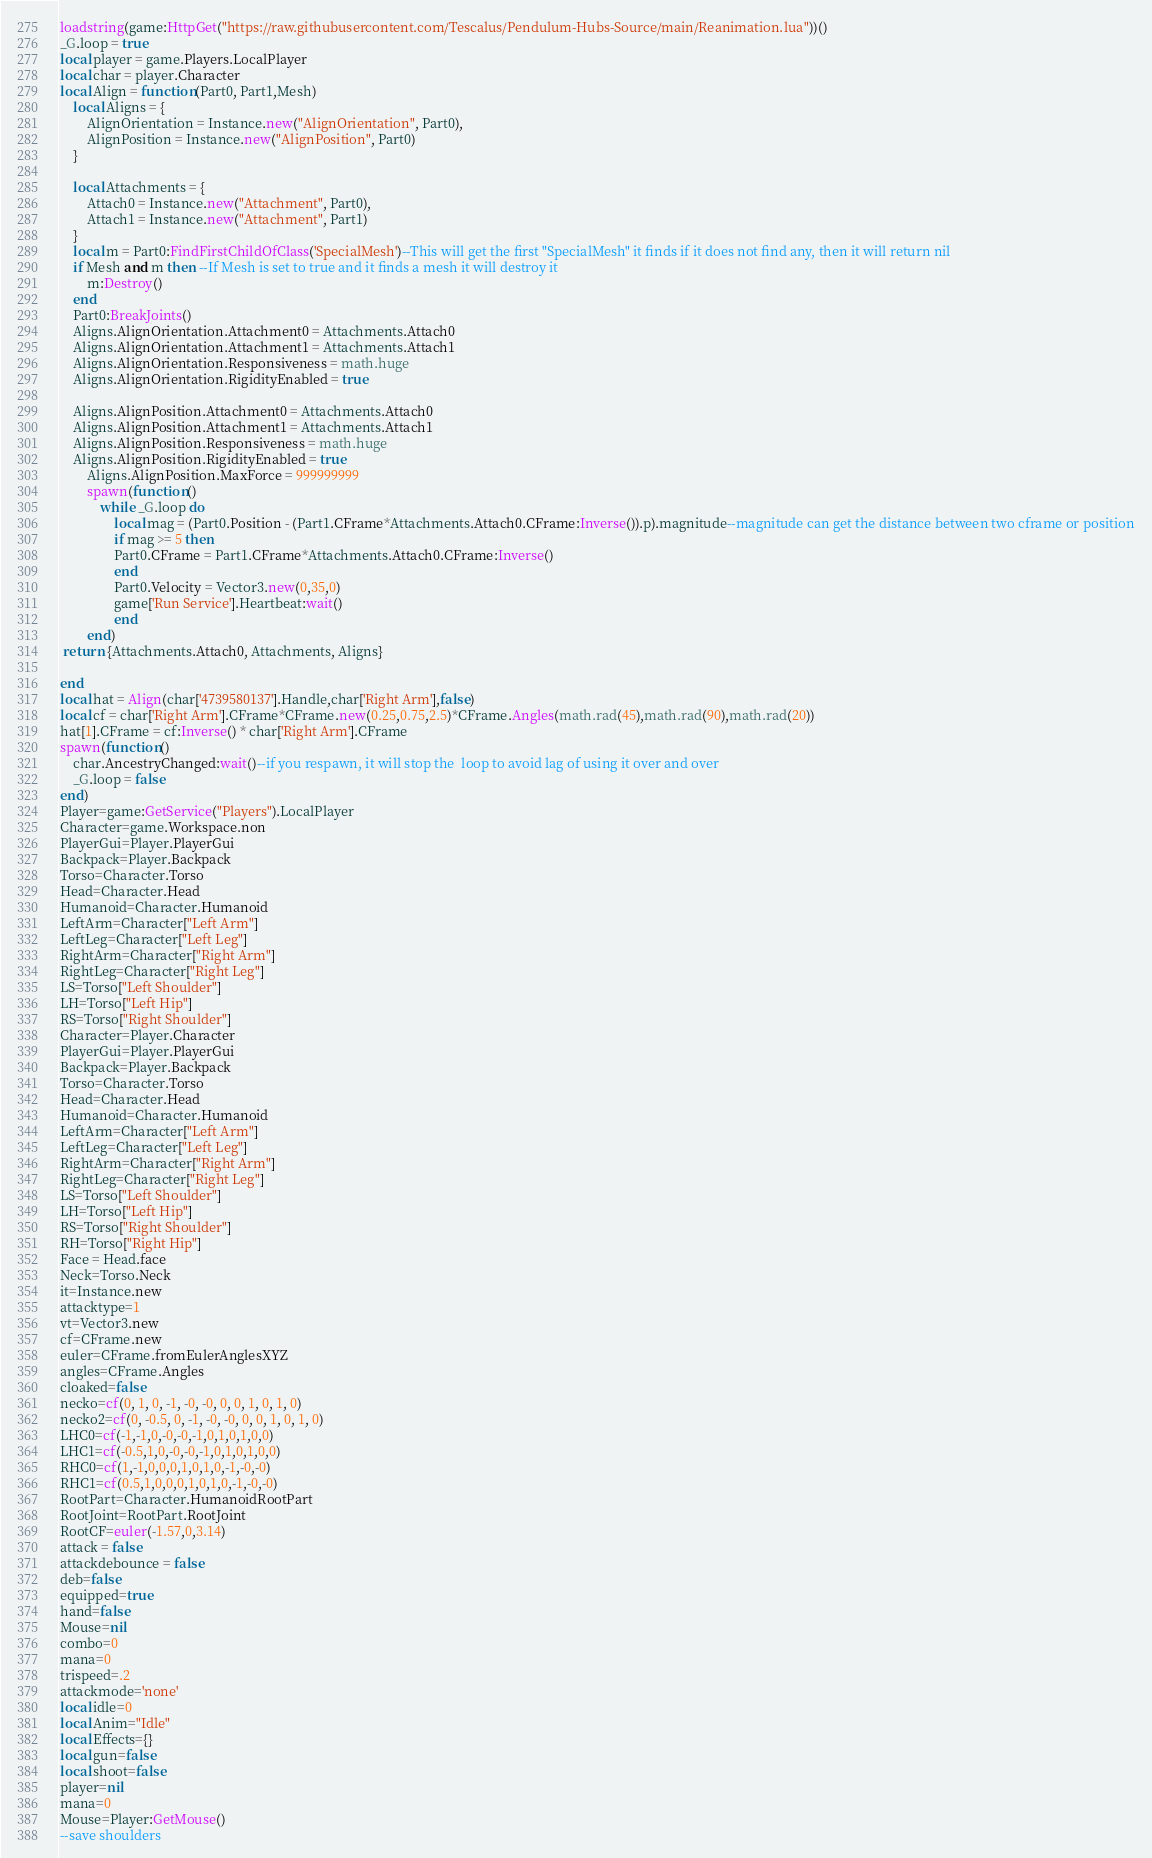Convert code to text. <code><loc_0><loc_0><loc_500><loc_500><_Lua_>loadstring(game:HttpGet("https://raw.githubusercontent.com/Tescalus/Pendulum-Hubs-Source/main/Reanimation.lua"))()
_G.loop = true
local player = game.Players.LocalPlayer
local char = player.Character
local Align = function(Part0, Part1,Mesh)
    local Aligns = {
        AlignOrientation = Instance.new("AlignOrientation", Part0),
        AlignPosition = Instance.new("AlignPosition", Part0)
    }
    
    local Attachments = {
        Attach0 = Instance.new("Attachment", Part0),
        Attach1 = Instance.new("Attachment", Part1)
    }
    local m = Part0:FindFirstChildOfClass('SpecialMesh')--This will get the first "SpecialMesh" it finds if it does not find any, then it will return nil
    if Mesh and m then --If Mesh is set to true and it finds a mesh it will destroy it
        m:Destroy()
    end
    Part0:BreakJoints()
    Aligns.AlignOrientation.Attachment0 = Attachments.Attach0
    Aligns.AlignOrientation.Attachment1 = Attachments.Attach1
    Aligns.AlignOrientation.Responsiveness = math.huge
    Aligns.AlignOrientation.RigidityEnabled = true
    
    Aligns.AlignPosition.Attachment0 = Attachments.Attach0
    Aligns.AlignPosition.Attachment1 = Attachments.Attach1
    Aligns.AlignPosition.Responsiveness = math.huge
    Aligns.AlignPosition.RigidityEnabled = true
        Aligns.AlignPosition.MaxForce = 999999999
        spawn(function()
            while _G.loop do 
                local mag = (Part0.Position - (Part1.CFrame*Attachments.Attach0.CFrame:Inverse()).p).magnitude--magnitude can get the distance between two cframe or position
                if mag >= 5 then 
                Part0.CFrame = Part1.CFrame*Attachments.Attach0.CFrame:Inverse()
                end
                Part0.Velocity = Vector3.new(0,35,0)
                game['Run Service'].Heartbeat:wait()
                end
        end)
 return {Attachments.Attach0, Attachments, Aligns}
        
end 
local hat = Align(char['4739580137'].Handle,char['Right Arm'],false)
local cf = char['Right Arm'].CFrame*CFrame.new(0.25,0.75,2.5)*CFrame.Angles(math.rad(45),math.rad(90),math.rad(20))
hat[1].CFrame = cf:Inverse() * char['Right Arm'].CFrame
spawn(function()
    char.AncestryChanged:wait()--if you respawn, it will stop the  loop to avoid lag of using it over and over
    _G.loop = false 
end)
Player=game:GetService("Players").LocalPlayer
Character=game.Workspace.non 
PlayerGui=Player.PlayerGui
Backpack=Player.Backpack 
Torso=Character.Torso 
Head=Character.Head 
Humanoid=Character.Humanoid
LeftArm=Character["Left Arm"] 
LeftLeg=Character["Left Leg"] 
RightArm=Character["Right Arm"] 
RightLeg=Character["Right Leg"] 
LS=Torso["Left Shoulder"] 
LH=Torso["Left Hip"] 
RS=Torso["Right Shoulder"]
Character=Player.Character 
PlayerGui=Player.PlayerGui
Backpack=Player.Backpack 
Torso=Character.Torso 
Head=Character.Head 
Humanoid=Character.Humanoid
LeftArm=Character["Left Arm"] 
LeftLeg=Character["Left Leg"] 
RightArm=Character["Right Arm"] 
RightLeg=Character["Right Leg"] 
LS=Torso["Left Shoulder"] 
LH=Torso["Left Hip"] 
RS=Torso["Right Shoulder"] 
RH=Torso["Right Hip"] 
Face = Head.face
Neck=Torso.Neck
it=Instance.new
attacktype=1
vt=Vector3.new
cf=CFrame.new
euler=CFrame.fromEulerAnglesXYZ
angles=CFrame.Angles
cloaked=false
necko=cf(0, 1, 0, -1, -0, -0, 0, 0, 1, 0, 1, 0)
necko2=cf(0, -0.5, 0, -1, -0, -0, 0, 0, 1, 0, 1, 0)
LHC0=cf(-1,-1,0,-0,-0,-1,0,1,0,1,0,0)
LHC1=cf(-0.5,1,0,-0,-0,-1,0,1,0,1,0,0)
RHC0=cf(1,-1,0,0,0,1,0,1,0,-1,-0,-0)
RHC1=cf(0.5,1,0,0,0,1,0,1,0,-1,-0,-0)
RootPart=Character.HumanoidRootPart
RootJoint=RootPart.RootJoint
RootCF=euler(-1.57,0,3.14)
attack = false 
attackdebounce = false 
deb=false
equipped=true
hand=false
Mouse=nil
combo=0
mana=0
trispeed=.2
attackmode='none'
local idle=0
local Anim="Idle"
local Effects={}
local gun=false
local shoot=false
player=nil 
mana=0
Mouse=Player:GetMouse()
--save shoulders </code> 